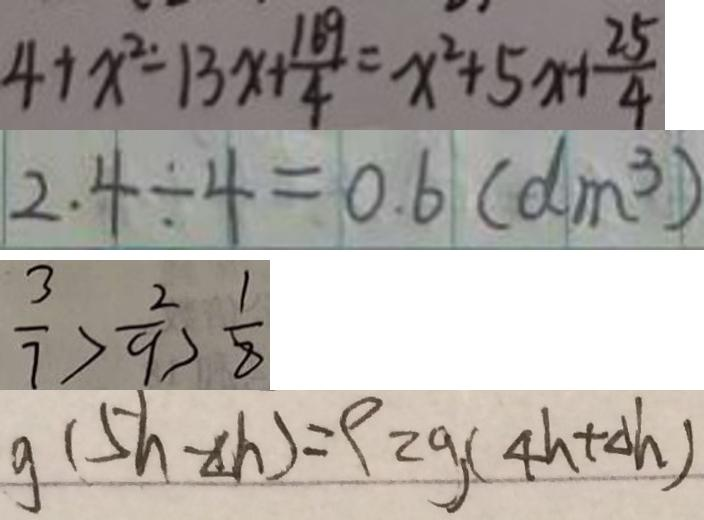Convert formula to latex. <formula><loc_0><loc_0><loc_500><loc_500>4 + x ^ { 2 } - 1 3 x + \frac { 1 6 9 } { 4 } = x ^ { 2 } + 5 x + \frac { 2 5 } { 4 } 
 2 . 4 \div 4 = 0 . 6 ( d m ^ { 3 } ) 
 \frac { 3 } { 7 } > \frac { 2 } { 9 } > \frac { 1 } { 8 } 
 g ( 5 h - \Delta h ) = \rho _ { z g } ( 4 h + \Delta h )</formula> 